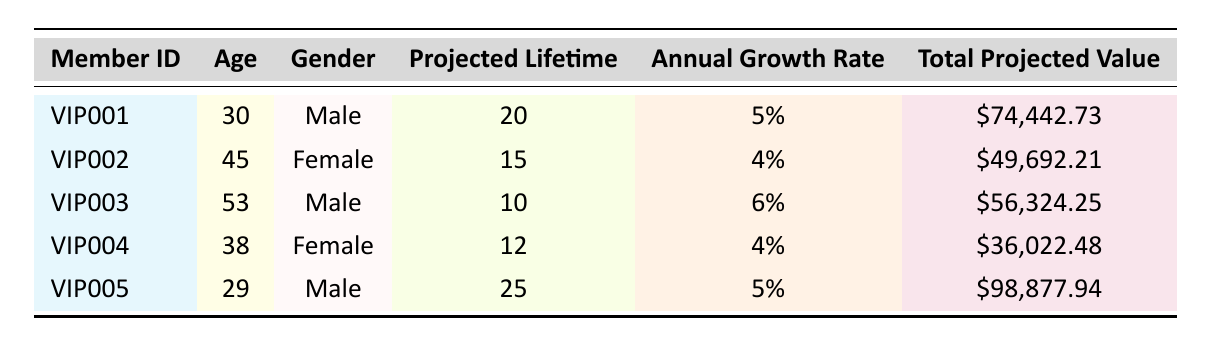What is the total projected value for member VIP001? The table directly states that the total projected value for member VIP001 is \$74,442.73.
Answer: \$74,442.73 Which member has the highest initial deposit? By looking at the initial deposit amounts, VIP005 has an initial deposit of \$12,000, which is the highest among all members listed.
Answer: VIP005 What is the average age of all the members? To calculate the average age, we sum all the ages (30 + 45 + 53 + 38 + 29) = 195 and divide by the total number of members, which is 5. So, 195/5 = 39.
Answer: 39 Is the total projected value of VIP002 greater than that of VIP004? The total projected value of VIP002 is \$49,692.21 and VIP004 is \$36,022.48. Since \$49,692.21 is greater than \$36,022.48, the statement is true.
Answer: Yes How much more is the total projected value of VIP005 compared to VIP003? To find the difference, we subtract the total projected value of VIP003 from that of VIP005: \$98,877.94 - \$56,324.25 = \$42,553.69.
Answer: \$42,553.69 What proportion of the members are male? There are 3 male members (VIP001, VIP003, and VIP005) out of a total of 5 members. Therefore, the proportion of male members is 3/5 = 0.6 or 60%.
Answer: 60% Which member has the shortest projected lifetime? The member with the shortest projected lifetime is VIP003, with a projected lifetime of 10 years.
Answer: VIP003 What is the average annual growth rate for the members? The average annual growth rate can be calculated by summing the annual growth rates (0.05 + 0.04 + 0.06 + 0.04 + 0.05) = 0.24 and dividing by the number of members: 0.24/5 = 0.048 or 4.8%.
Answer: 4.8% Which member is projected to have a total projected value less than \$40,000? From the table, VIP004 has a total projected value of \$36,022.48, which is less than \$40,000.
Answer: VIP004 